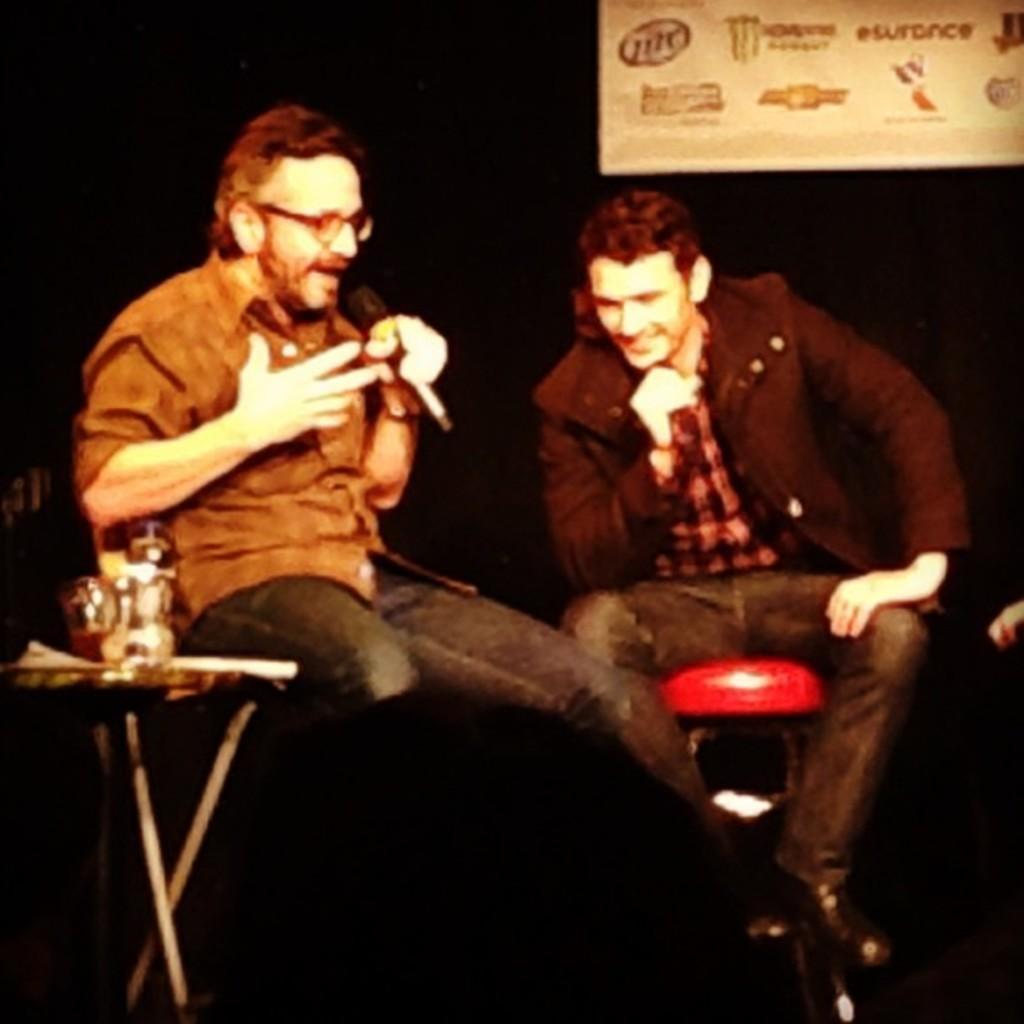How would you summarize this image in a sentence or two? In the picture we can see two men are sitting on the table and they are holding a microphone and one man is talking something. 